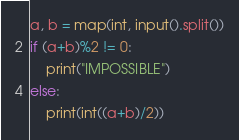Convert code to text. <code><loc_0><loc_0><loc_500><loc_500><_Python_>a, b = map(int, input().split())
if (a+b)%2 != 0:
    print("IMPOSSIBLE")
else:
    print(int((a+b)/2))</code> 